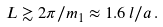Convert formula to latex. <formula><loc_0><loc_0><loc_500><loc_500>L \gtrsim 2 \pi / m _ { 1 } \approx 1 . 6 \, l / a \, .</formula> 